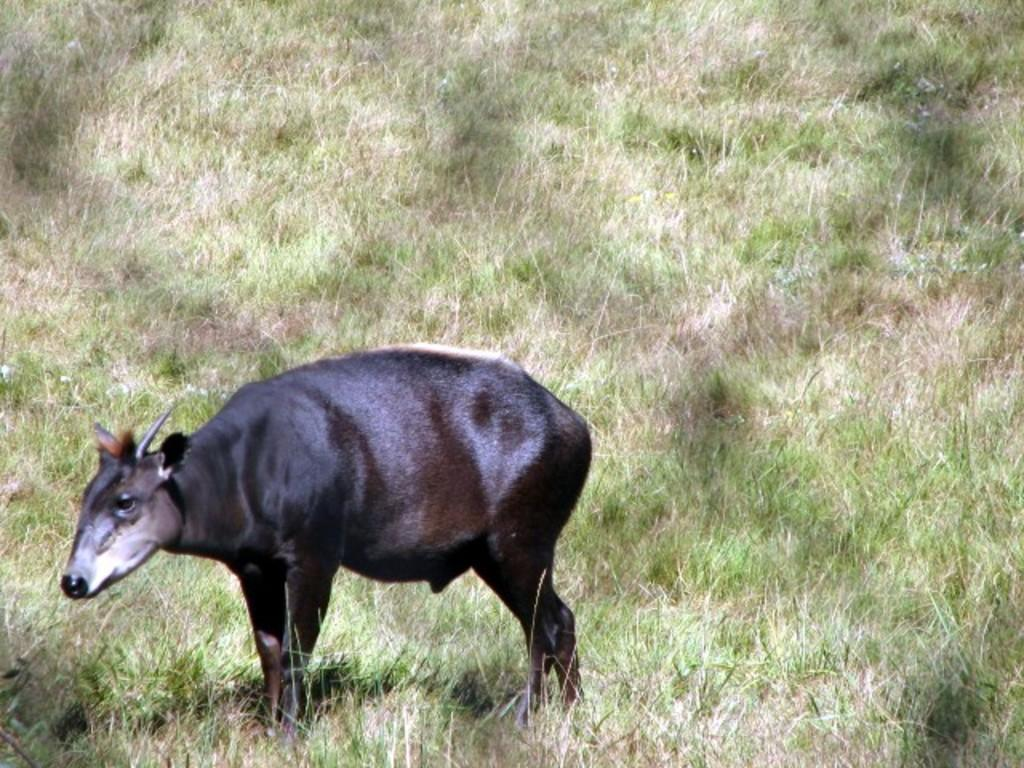What type of animal is in the image? The type of animal cannot be determined from the provided facts. What can be seen in the background of the image? There is grass visible in the background of the image. How many sisters does the animal have in the image? There is no information about any sisters in the image, as it only features an animal and grass in the background. 